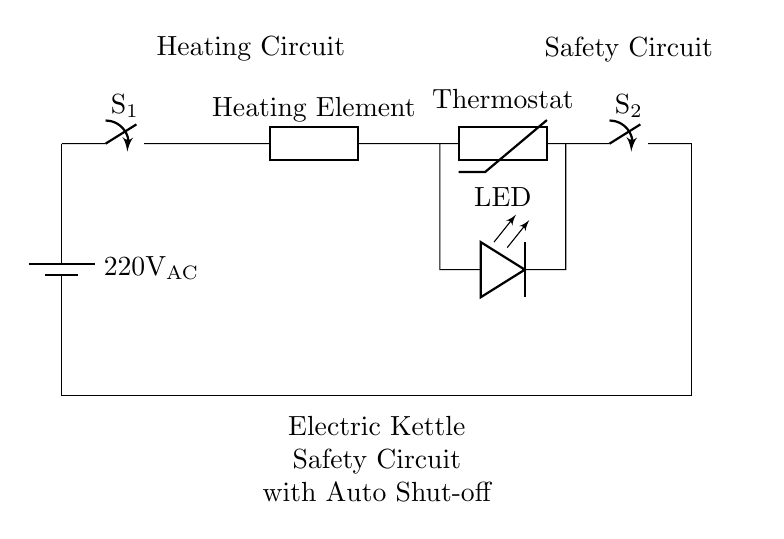What is the power source voltage? The circuit is powered by an AC voltage of 220 volts, as indicated by the label on the battery symbol.
Answer: 220 Volts AC What component is responsible for controlling the temperature? The component labeled as "Thermostat" is a thermistor, which detects temperature changes and helps regulate the kettle's heating.
Answer: Thermostat What does the LED indicate in the circuit? The LED is included in the circuit to provide visual feedback, signaling whether the kettle is in operation. When the kettle is heating, the LED lights up.
Answer: Operation status How many switches are present in the circuit? There are two switches indicated in the circuit diagram; one is labeled S1 and the other S2.
Answer: Two switches What role does the auto shut-off switch play? The auto shut-off switch (S2) is designed to disconnect the heating element from the power supply once the desired temperature is reached, ensuring safety.
Answer: Safety disconnection What happens to the circuit when the thermostat reaches the set temperature? Once the thermostat detects that the water has reached the set temperature, it opens the circuit at switch S2, thus preventing further heating and ensuring safety.
Answer: Circuit opens 